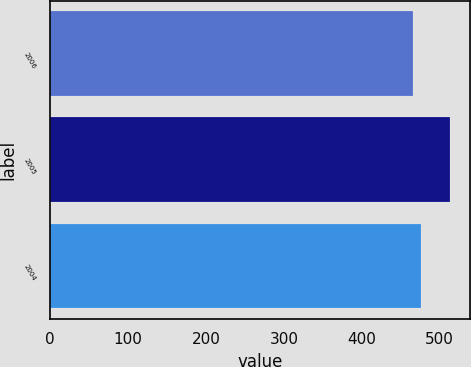Convert chart. <chart><loc_0><loc_0><loc_500><loc_500><bar_chart><fcel>2006<fcel>2005<fcel>2004<nl><fcel>465.5<fcel>513.4<fcel>475.5<nl></chart> 